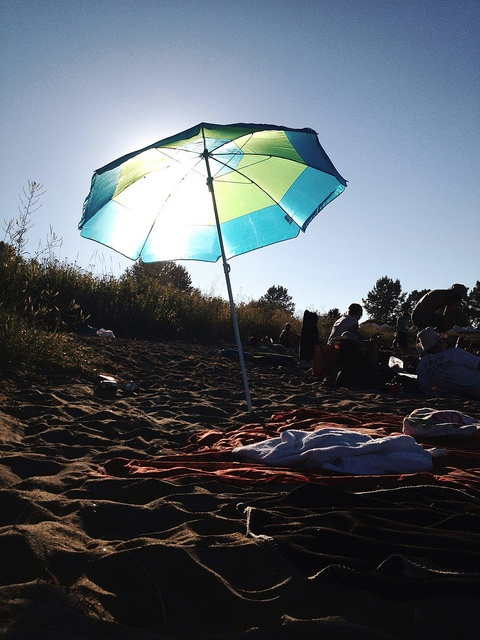Describe the objects in this image and their specific colors. I can see umbrella in gray, white, khaki, and lightblue tones, people in gray, black, and darkgray tones, people in gray, black, darkgray, and lightgray tones, people in gray, black, darkgray, and lightgray tones, and people in gray, black, and maroon tones in this image. 